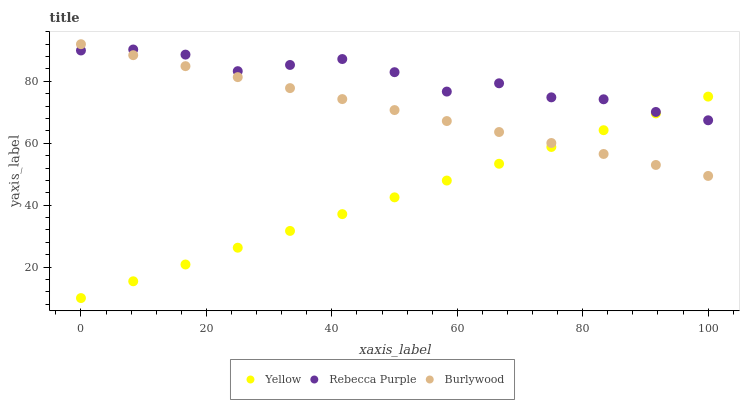Does Yellow have the minimum area under the curve?
Answer yes or no. Yes. Does Rebecca Purple have the maximum area under the curve?
Answer yes or no. Yes. Does Rebecca Purple have the minimum area under the curve?
Answer yes or no. No. Does Yellow have the maximum area under the curve?
Answer yes or no. No. Is Yellow the smoothest?
Answer yes or no. Yes. Is Rebecca Purple the roughest?
Answer yes or no. Yes. Is Rebecca Purple the smoothest?
Answer yes or no. No. Is Yellow the roughest?
Answer yes or no. No. Does Yellow have the lowest value?
Answer yes or no. Yes. Does Rebecca Purple have the lowest value?
Answer yes or no. No. Does Burlywood have the highest value?
Answer yes or no. Yes. Does Rebecca Purple have the highest value?
Answer yes or no. No. Does Rebecca Purple intersect Yellow?
Answer yes or no. Yes. Is Rebecca Purple less than Yellow?
Answer yes or no. No. Is Rebecca Purple greater than Yellow?
Answer yes or no. No. 